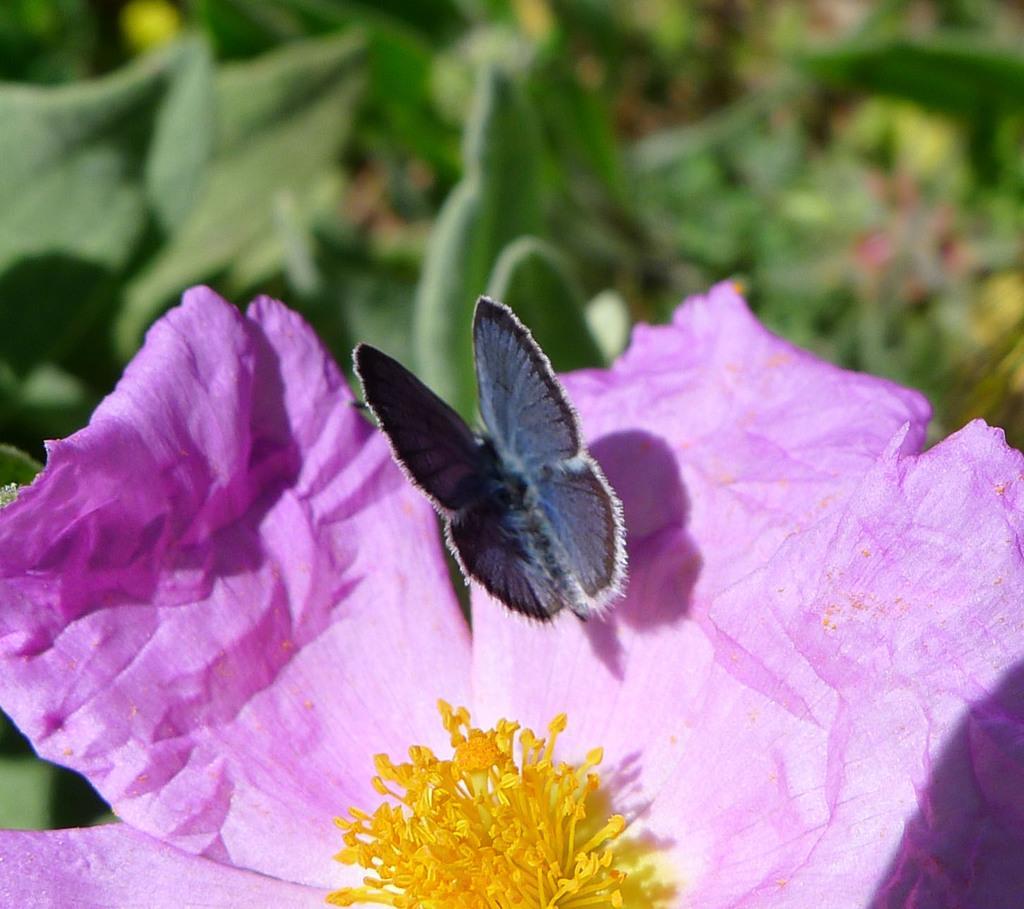Could you give a brief overview of what you see in this image? Inn this image there is a violet colour flower having a butterfly on the petal. Behind it there are few plants having leaves. 